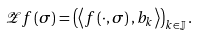<formula> <loc_0><loc_0><loc_500><loc_500>\mathcal { Z } f \left ( \sigma \right ) = \left ( \left \langle f \left ( \cdot , \sigma \right ) , b _ { k } \right \rangle \right ) _ { k \in \mathbb { J } } .</formula> 